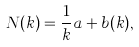Convert formula to latex. <formula><loc_0><loc_0><loc_500><loc_500>N ( k ) = \frac { 1 } { k } a + b ( k ) ,</formula> 